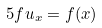Convert formula to latex. <formula><loc_0><loc_0><loc_500><loc_500>\ 5 { f } { u _ { x } } = f ( x )</formula> 